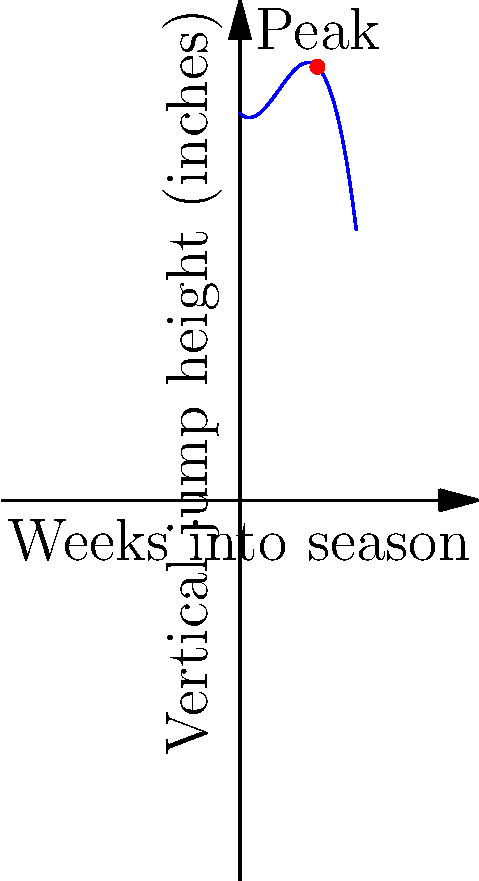The graph shows your vertical jump height (in inches) over the course of a 12-week basketball season. The curve is modeled by the function $f(x) = -0.05x^3 + 0.6x^2 - x + 40$, where $x$ represents the number of weeks into the season. At which week does your vertical jump height reach its maximum, and what is this maximum height to the nearest inch? To find the maximum point of the function, we need to follow these steps:

1) Find the derivative of the function:
   $f'(x) = -0.15x^2 + 1.2x - 1$

2) Set the derivative equal to zero and solve for x:
   $-0.15x^2 + 1.2x - 1 = 0$
   
3) This is a quadratic equation. We can solve it using the quadratic formula:
   $x = \frac{-b \pm \sqrt{b^2 - 4ac}}{2a}$
   
   Where $a = -0.15$, $b = 1.2$, and $c = -1$

4) Plugging in these values:
   $x = \frac{-1.2 \pm \sqrt{1.44 - 4(-0.15)(-1)}}{2(-0.15)}$
   $= \frac{-1.2 \pm \sqrt{1.44 - 0.6}}{-0.3}$
   $= \frac{-1.2 \pm \sqrt{0.84}}{-0.3}$
   $= \frac{-1.2 \pm 0.9165}{-0.3}$

5) This gives us two solutions:
   $x_1 = \frac{-1.2 + 0.9165}{-0.3} \approx 0.945$
   $x_2 = \frac{-1.2 - 0.9165}{-0.3} \approx 7.055$

6) Since we're looking for a maximum within the season (0-12 weeks), $x_2 \approx 7.055$ is our solution.

7) Rounding to the nearest whole number (as we're dealing with weeks), the maximum occurs at week 8.

8) To find the maximum height, we plug x = 8 into our original function:
   $f(8) = -0.05(8^3) + 0.6(8^2) - 8 + 40$
   $= -25.6 + 38.4 - 8 + 40$
   $= 44.8$

9) Rounding to the nearest inch, the maximum height is 45 inches.
Answer: Week 8, 45 inches 